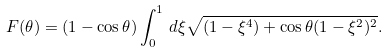Convert formula to latex. <formula><loc_0><loc_0><loc_500><loc_500>F ( \theta ) = ( 1 - \cos \theta ) \int _ { 0 } ^ { 1 } \, d \xi \sqrt { ( 1 - \xi ^ { 4 } ) + \cos \theta ( 1 - \xi ^ { 2 } ) ^ { 2 } } .</formula> 